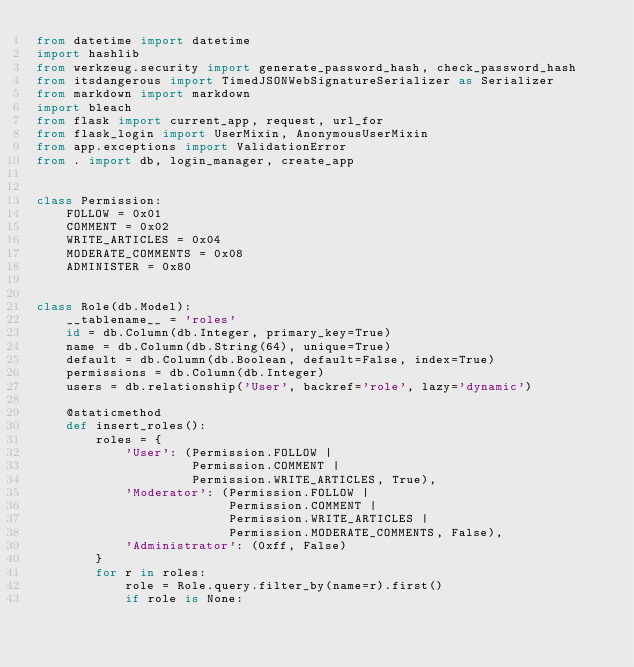<code> <loc_0><loc_0><loc_500><loc_500><_Python_>from datetime import datetime
import hashlib
from werkzeug.security import generate_password_hash, check_password_hash
from itsdangerous import TimedJSONWebSignatureSerializer as Serializer
from markdown import markdown
import bleach
from flask import current_app, request, url_for
from flask_login import UserMixin, AnonymousUserMixin
from app.exceptions import ValidationError
from . import db, login_manager, create_app


class Permission:
    FOLLOW = 0x01
    COMMENT = 0x02
    WRITE_ARTICLES = 0x04
    MODERATE_COMMENTS = 0x08
    ADMINISTER = 0x80


class Role(db.Model):
    __tablename__ = 'roles'
    id = db.Column(db.Integer, primary_key=True)
    name = db.Column(db.String(64), unique=True)
    default = db.Column(db.Boolean, default=False, index=True)
    permissions = db.Column(db.Integer)
    users = db.relationship('User', backref='role', lazy='dynamic')

    @staticmethod
    def insert_roles():
        roles = {
            'User': (Permission.FOLLOW |
                     Permission.COMMENT |
                     Permission.WRITE_ARTICLES, True),
            'Moderator': (Permission.FOLLOW |
                          Permission.COMMENT |
                          Permission.WRITE_ARTICLES |
                          Permission.MODERATE_COMMENTS, False),
            'Administrator': (0xff, False)
        }
        for r in roles:
            role = Role.query.filter_by(name=r).first()
            if role is None:</code> 